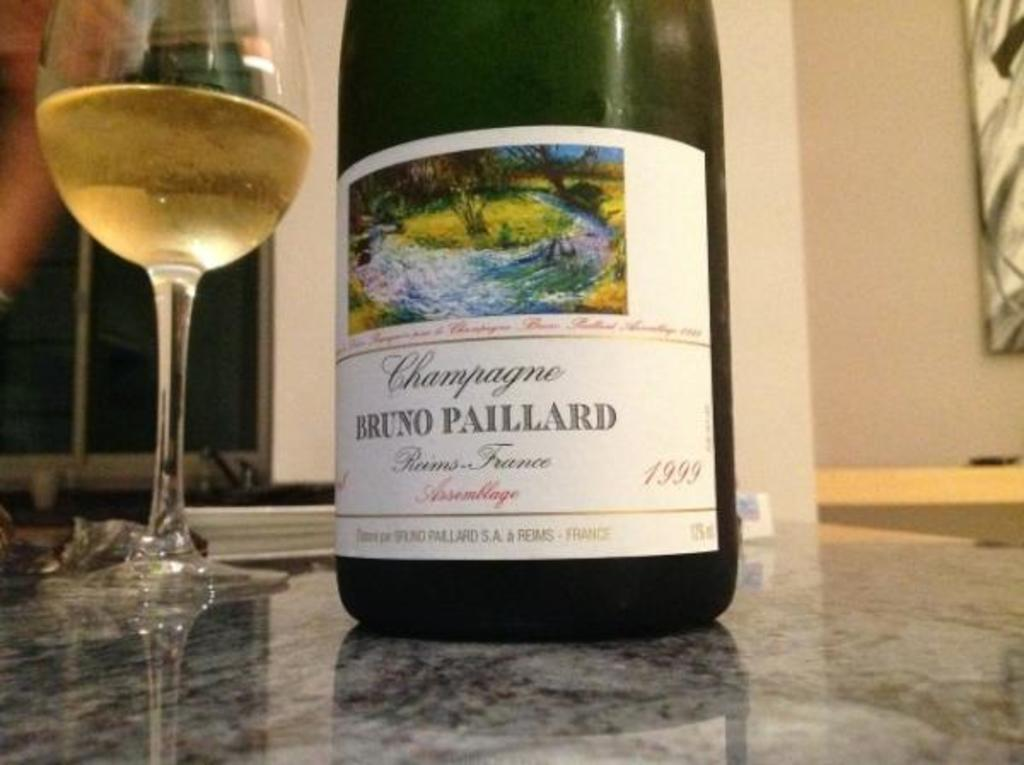Provide a one-sentence caption for the provided image. A Bruno Paillard bottle of wine is next to a poured glass of wine. 